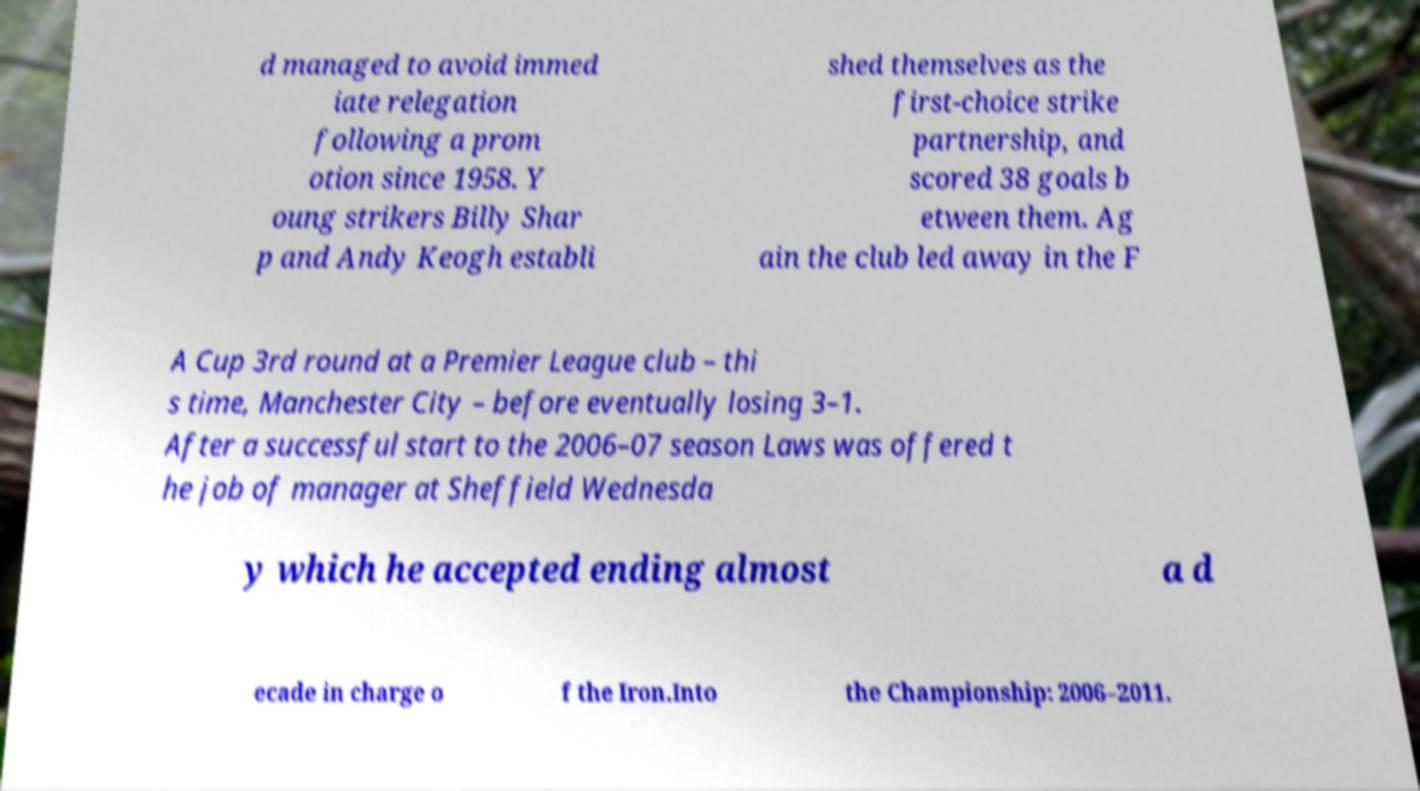Could you extract and type out the text from this image? d managed to avoid immed iate relegation following a prom otion since 1958. Y oung strikers Billy Shar p and Andy Keogh establi shed themselves as the first-choice strike partnership, and scored 38 goals b etween them. Ag ain the club led away in the F A Cup 3rd round at a Premier League club – thi s time, Manchester City – before eventually losing 3–1. After a successful start to the 2006–07 season Laws was offered t he job of manager at Sheffield Wednesda y which he accepted ending almost a d ecade in charge o f the Iron.Into the Championship: 2006–2011. 